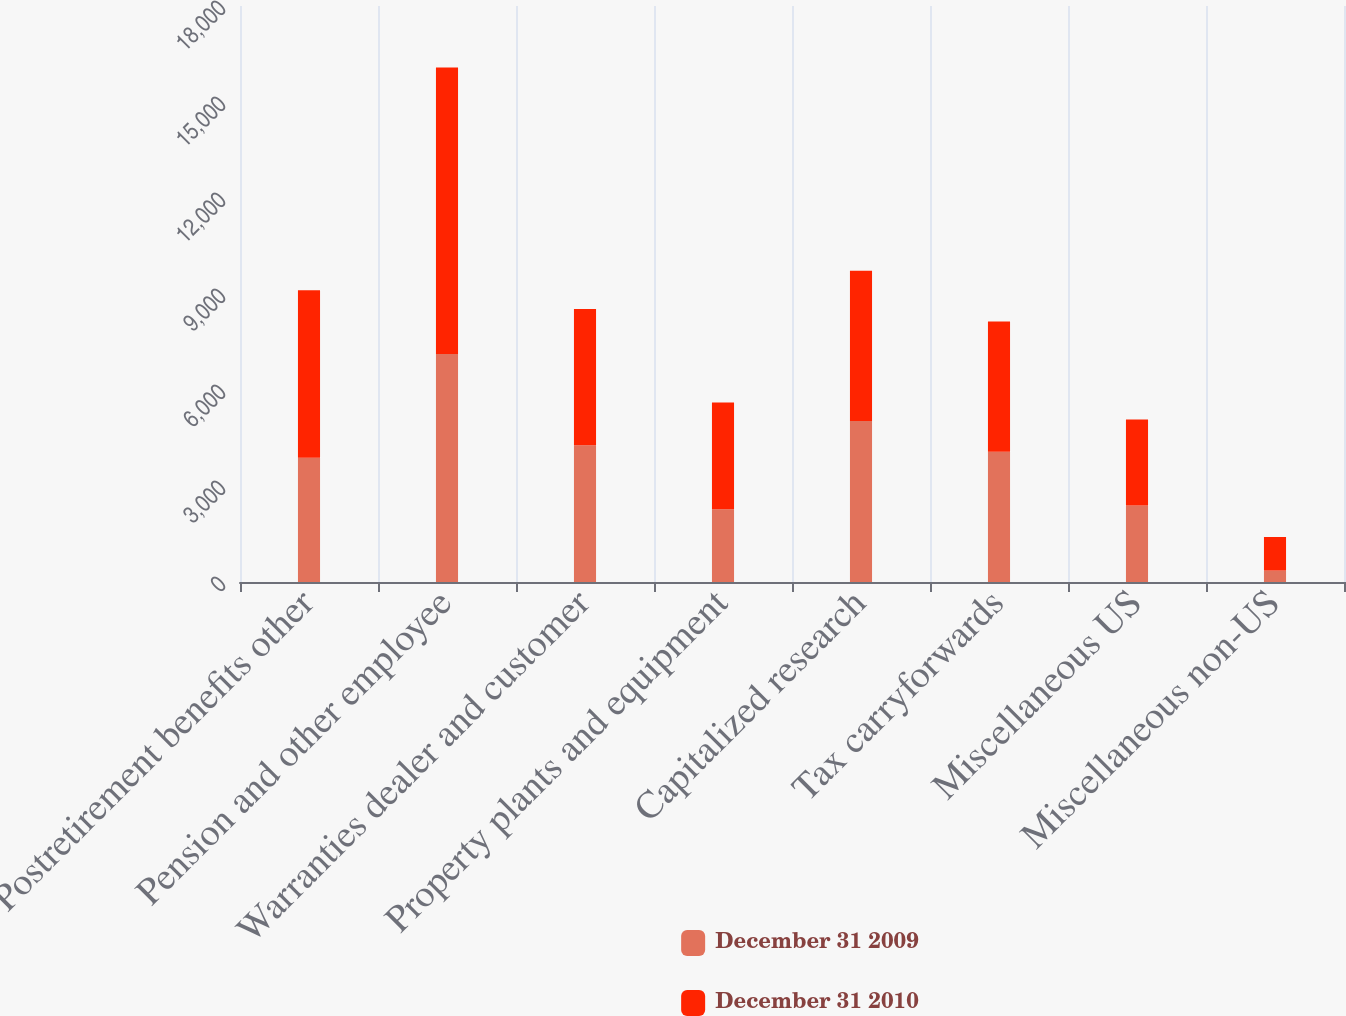<chart> <loc_0><loc_0><loc_500><loc_500><stacked_bar_chart><ecel><fcel>Postretirement benefits other<fcel>Pension and other employee<fcel>Warranties dealer and customer<fcel>Property plants and equipment<fcel>Capitalized research<fcel>Tax carryforwards<fcel>Miscellaneous US<fcel>Miscellaneous non-US<nl><fcel>December 31 2009<fcel>3884<fcel>7127<fcel>4276<fcel>2275<fcel>5033<fcel>4069.5<fcel>2387<fcel>357<nl><fcel>December 31 2010<fcel>5231<fcel>8951<fcel>4255<fcel>3333<fcel>4693<fcel>4069.5<fcel>2693<fcel>1049<nl></chart> 